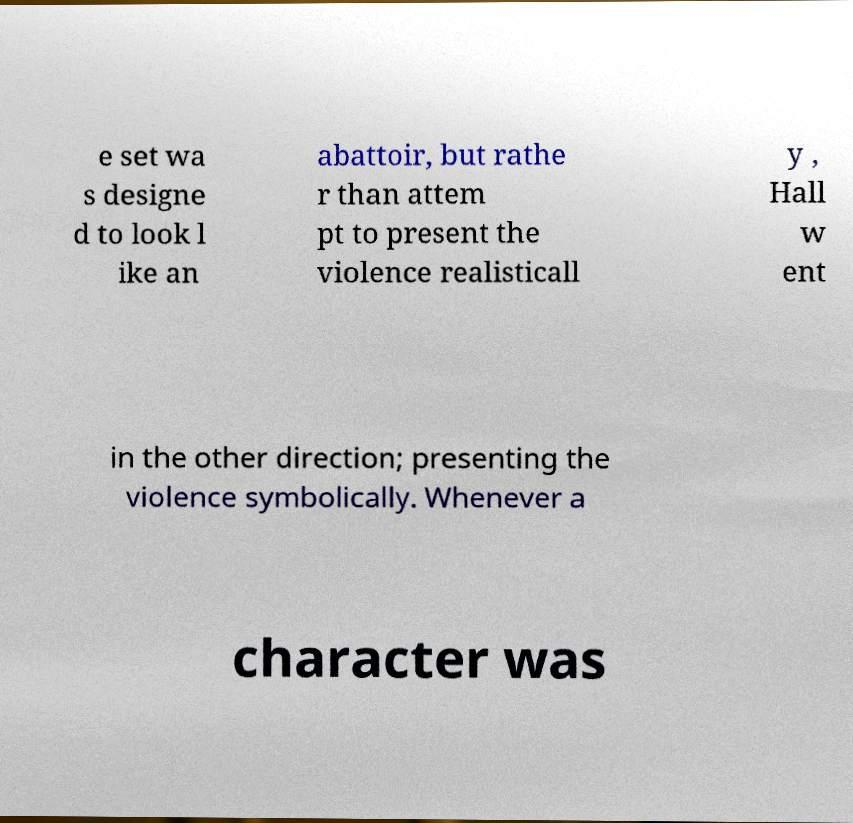There's text embedded in this image that I need extracted. Can you transcribe it verbatim? e set wa s designe d to look l ike an abattoir, but rathe r than attem pt to present the violence realisticall y , Hall w ent in the other direction; presenting the violence symbolically. Whenever a character was 